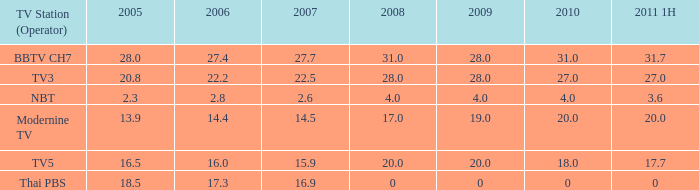What is the number of 2008 values having a 2006 under 17.3, 2010 over 4, and 2011 1H of 20? 1.0. 